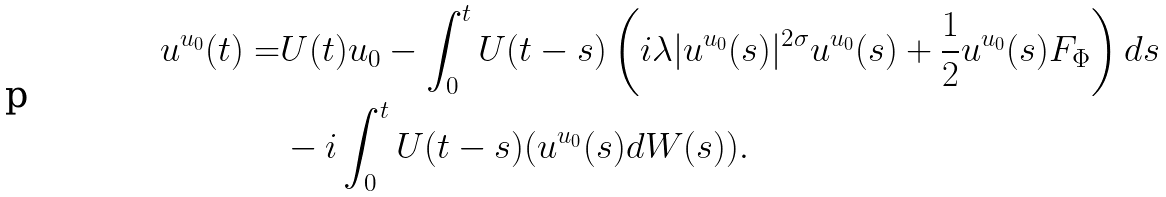Convert formula to latex. <formula><loc_0><loc_0><loc_500><loc_500>u ^ { u _ { 0 } } ( t ) = & U ( t ) u _ { 0 } - \int _ { 0 } ^ { t } U ( t - s ) \left ( i \lambda | u ^ { u _ { 0 } } ( s ) | ^ { 2 \sigma } u ^ { u _ { 0 } } ( s ) + \frac { 1 } { 2 } u ^ { u _ { 0 } } ( s ) F _ { \Phi } \right ) d s \\ & - i \int _ { 0 } ^ { t } U ( t - s ) ( u ^ { u _ { 0 } } ( s ) d W ( s ) ) .</formula> 